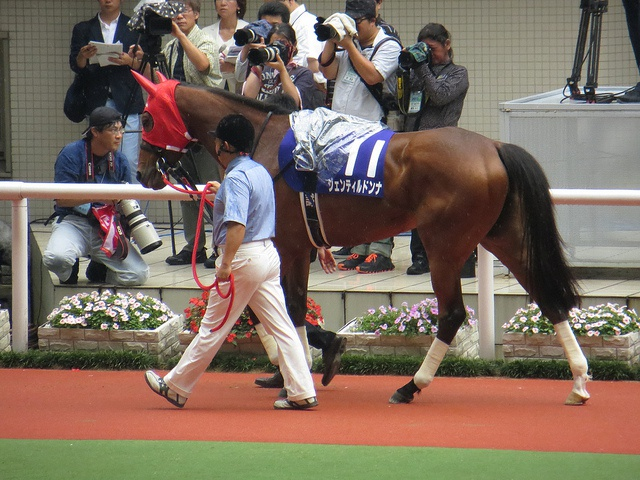Describe the objects in this image and their specific colors. I can see horse in black, maroon, and gray tones, people in black, lightgray, salmon, and darkgray tones, people in black, gray, navy, and maroon tones, potted plant in black, gray, darkgreen, white, and darkgray tones, and people in black, gray, darkgray, and maroon tones in this image. 